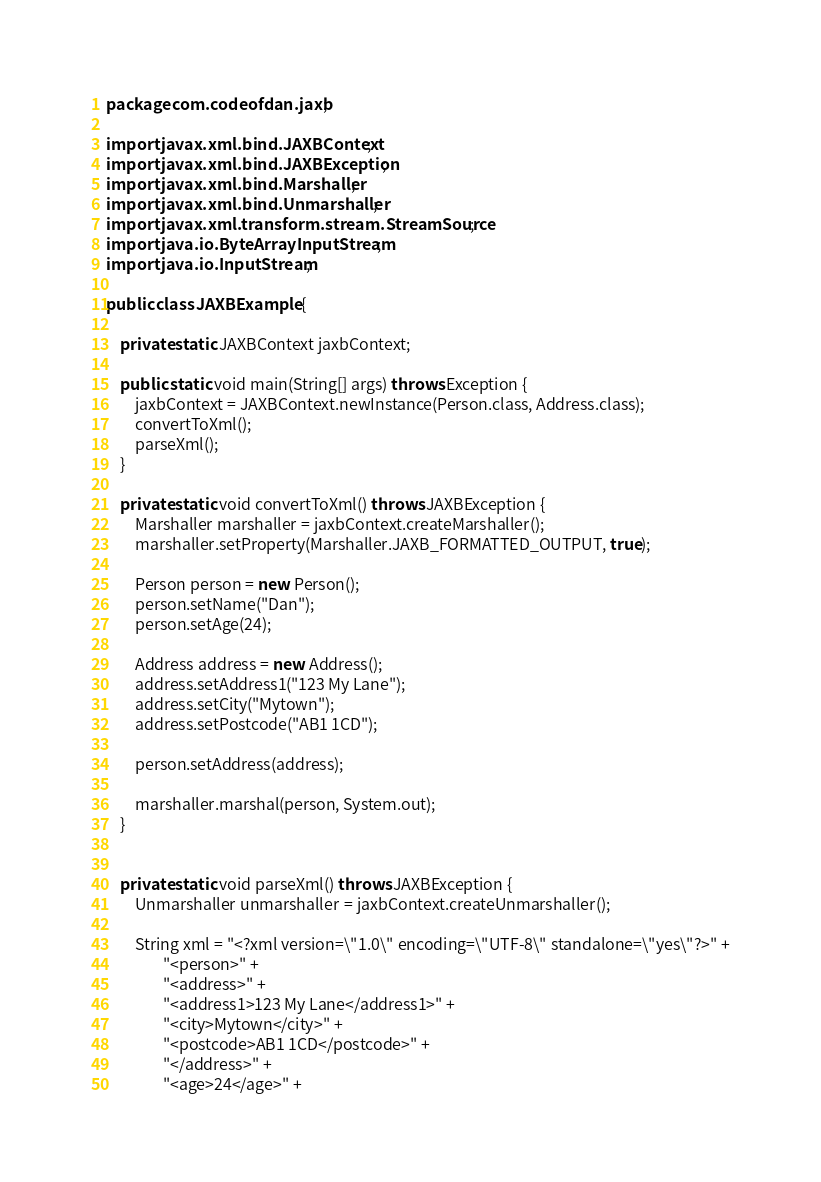<code> <loc_0><loc_0><loc_500><loc_500><_Java_>package com.codeofdan.jaxb;

import javax.xml.bind.JAXBContext;
import javax.xml.bind.JAXBException;
import javax.xml.bind.Marshaller;
import javax.xml.bind.Unmarshaller;
import javax.xml.transform.stream.StreamSource;
import java.io.ByteArrayInputStream;
import java.io.InputStream;

public class JAXBExample {

    private static JAXBContext jaxbContext;

    public static void main(String[] args) throws Exception {
        jaxbContext = JAXBContext.newInstance(Person.class, Address.class);
        convertToXml();
        parseXml();
    }

    private static void convertToXml() throws JAXBException {
        Marshaller marshaller = jaxbContext.createMarshaller();
        marshaller.setProperty(Marshaller.JAXB_FORMATTED_OUTPUT, true);

        Person person = new Person();
        person.setName("Dan");
        person.setAge(24);

        Address address = new Address();
        address.setAddress1("123 My Lane");
        address.setCity("Mytown");
        address.setPostcode("AB1 1CD");

        person.setAddress(address);

        marshaller.marshal(person, System.out);
    }


    private static void parseXml() throws JAXBException {
        Unmarshaller unmarshaller = jaxbContext.createUnmarshaller();

        String xml = "<?xml version=\"1.0\" encoding=\"UTF-8\" standalone=\"yes\"?>" +
                "<person>" +
                "<address>" +
                "<address1>123 My Lane</address1>" +
                "<city>Mytown</city>" +
                "<postcode>AB1 1CD</postcode>" +
                "</address>" +
                "<age>24</age>" +</code> 